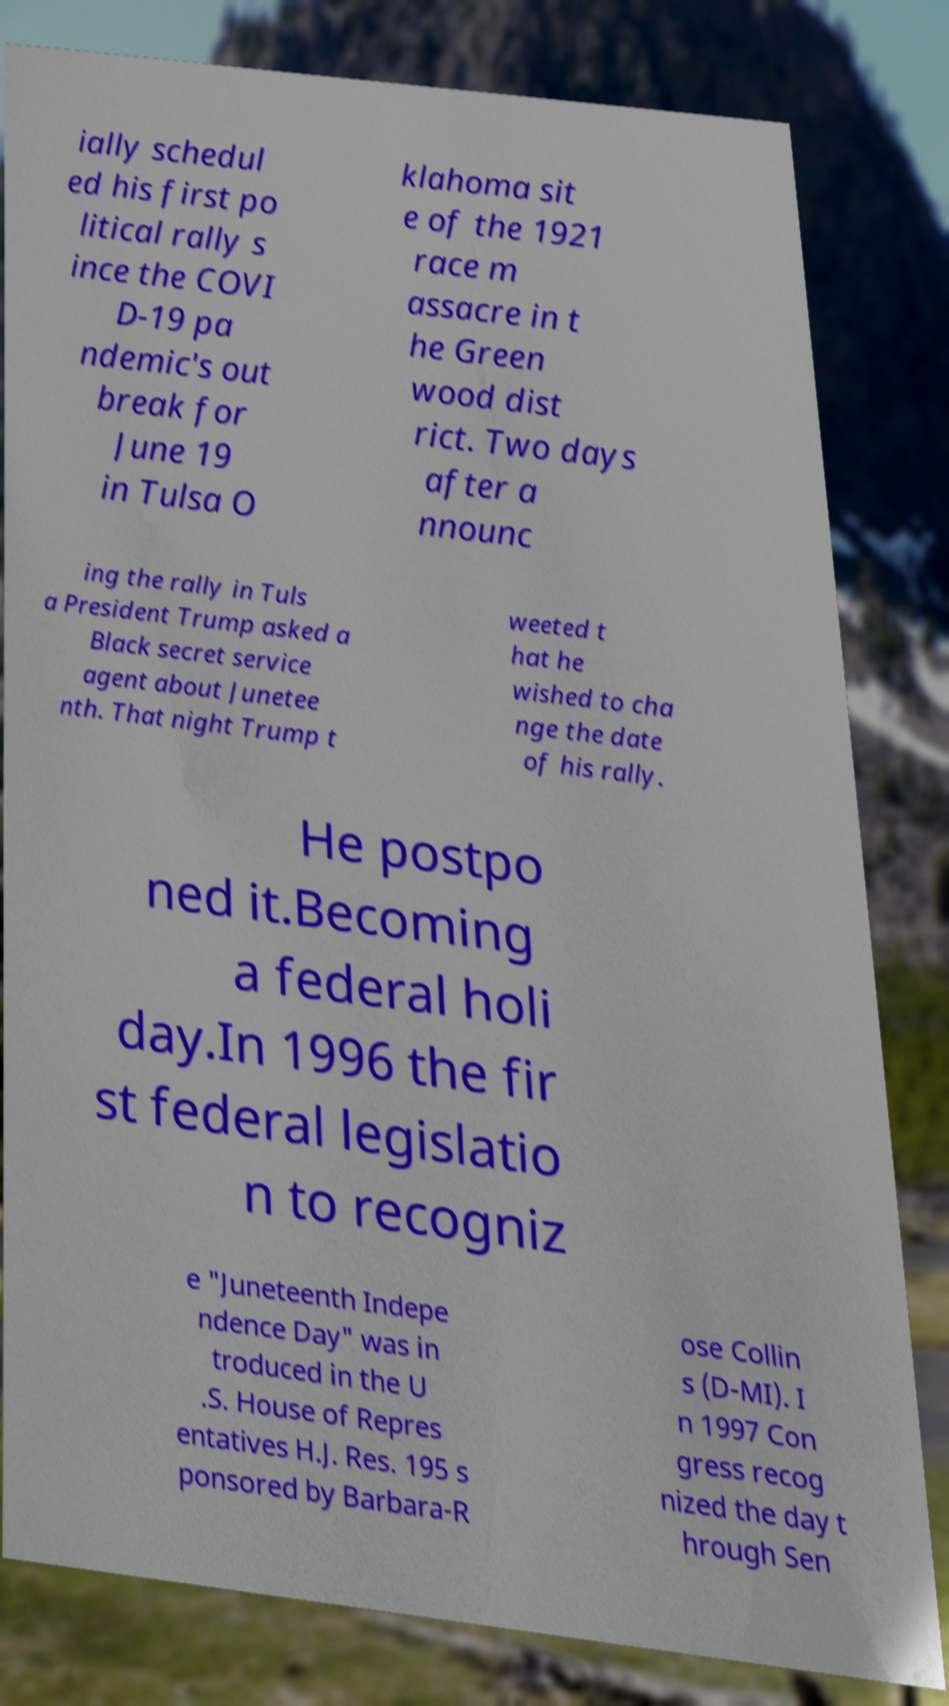Please identify and transcribe the text found in this image. ially schedul ed his first po litical rally s ince the COVI D-19 pa ndemic's out break for June 19 in Tulsa O klahoma sit e of the 1921 race m assacre in t he Green wood dist rict. Two days after a nnounc ing the rally in Tuls a President Trump asked a Black secret service agent about Junetee nth. That night Trump t weeted t hat he wished to cha nge the date of his rally. He postpo ned it.Becoming a federal holi day.In 1996 the fir st federal legislatio n to recogniz e "Juneteenth Indepe ndence Day" was in troduced in the U .S. House of Repres entatives H.J. Res. 195 s ponsored by Barbara-R ose Collin s (D-MI). I n 1997 Con gress recog nized the day t hrough Sen 